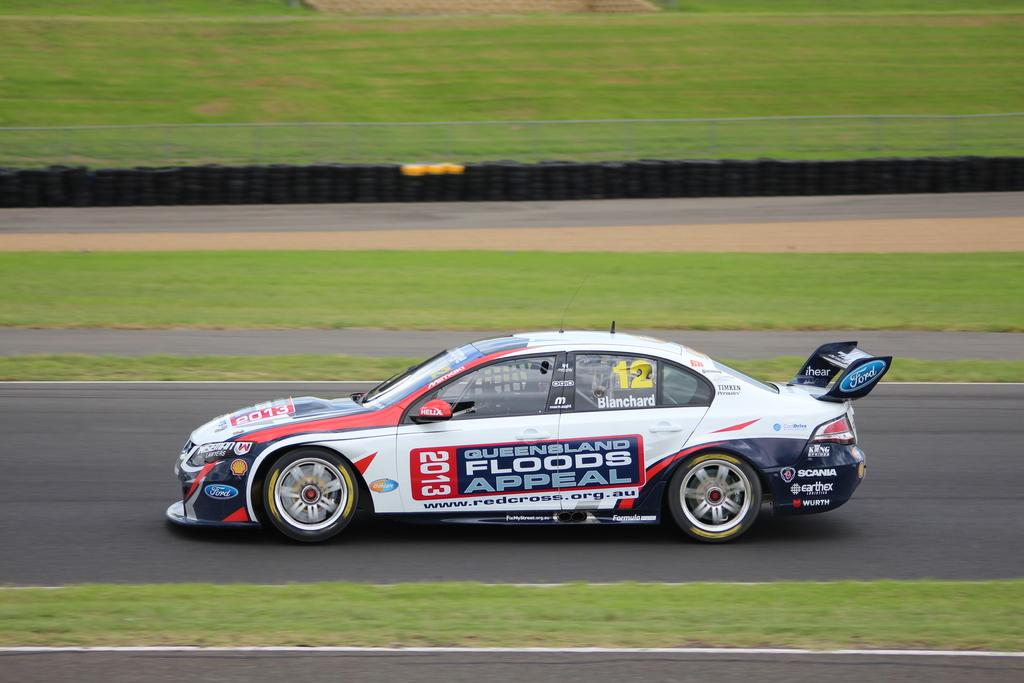What is the main subject of the image? There is a racing car in the image. Where is the racing car located? The racing car is on the road. What can be seen on both sides of the road? There is grass on both sides of the road. What else is present on the road in the background of the image? There are many tires placed on the road in the background. Where is the nearest library to the racing car in the image? There is no information about a library in the image, so it cannot be determined from the image. 